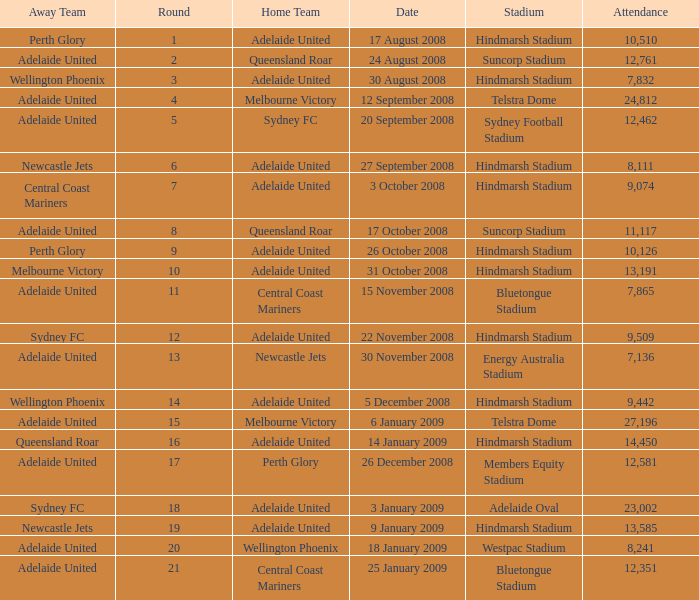What is the round when 11,117 people attended the game on 26 October 2008? 9.0. 